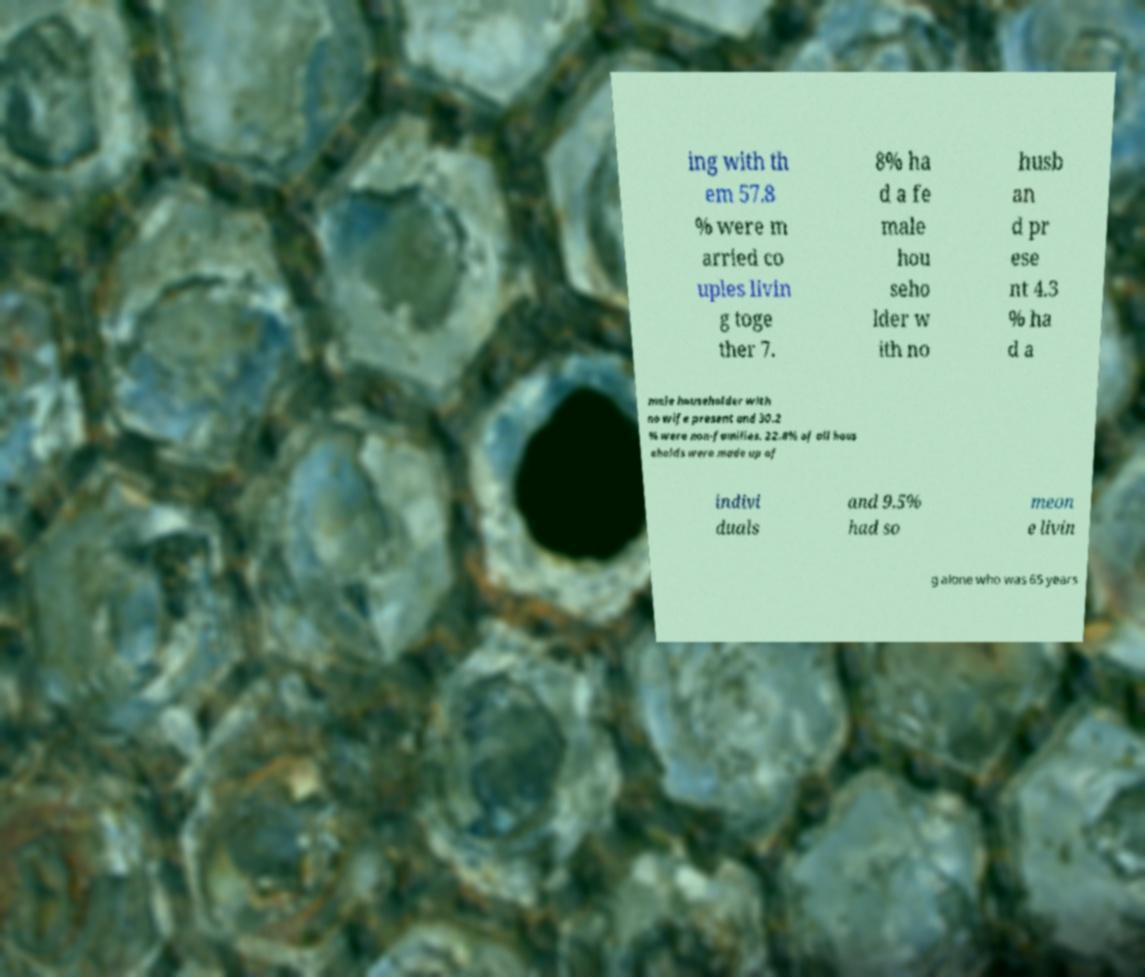Please read and relay the text visible in this image. What does it say? ing with th em 57.8 % were m arried co uples livin g toge ther 7. 8% ha d a fe male hou seho lder w ith no husb an d pr ese nt 4.3 % ha d a male householder with no wife present and 30.2 % were non-families. 22.8% of all hous eholds were made up of indivi duals and 9.5% had so meon e livin g alone who was 65 years 